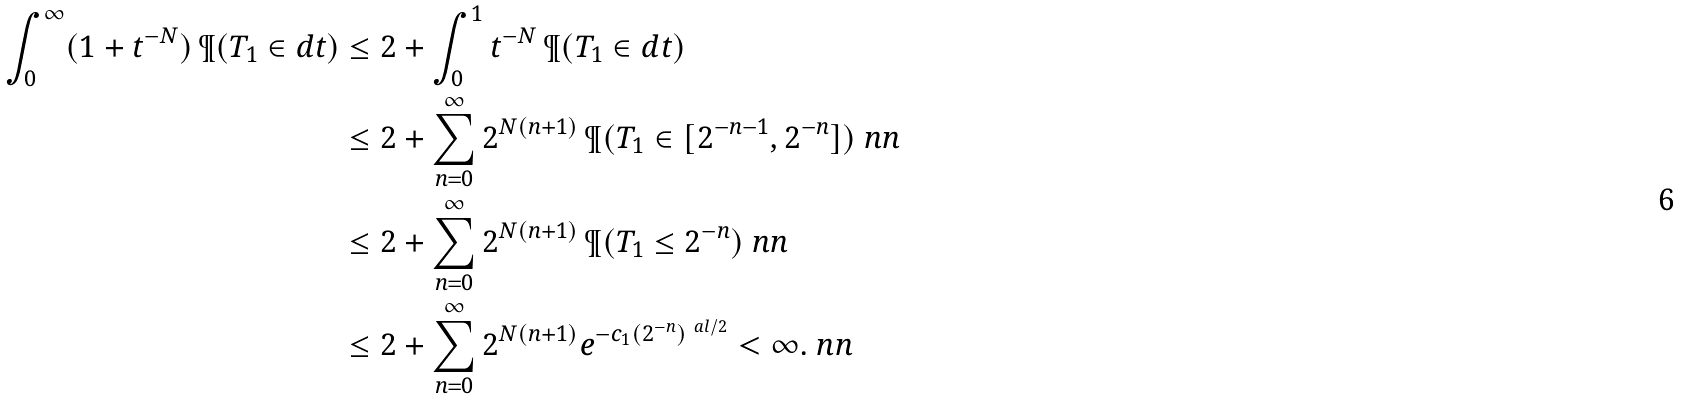Convert formula to latex. <formula><loc_0><loc_0><loc_500><loc_500>\int _ { 0 } ^ { \infty } ( 1 + t ^ { - N } ) \, \P ( T _ { 1 } \in d t ) & \leq 2 + \int _ { 0 } ^ { 1 } t ^ { - N } \, \P ( T _ { 1 } \in d t ) \\ & \leq 2 + \sum _ { n = 0 } ^ { \infty } 2 ^ { N ( n + 1 ) } \, \P ( T _ { 1 } \in [ 2 ^ { - n - 1 } , 2 ^ { - n } ] ) \ n n \\ & \leq 2 + \sum _ { n = 0 } ^ { \infty } 2 ^ { N ( n + 1 ) } \, \P ( T _ { 1 } \leq 2 ^ { - n } ) \ n n \\ & \leq 2 + \sum _ { n = 0 } ^ { \infty } 2 ^ { N ( n + 1 ) } e ^ { - c _ { 1 } ( 2 ^ { - n } ) ^ { \ a l / 2 } } < \infty . \ n n</formula> 